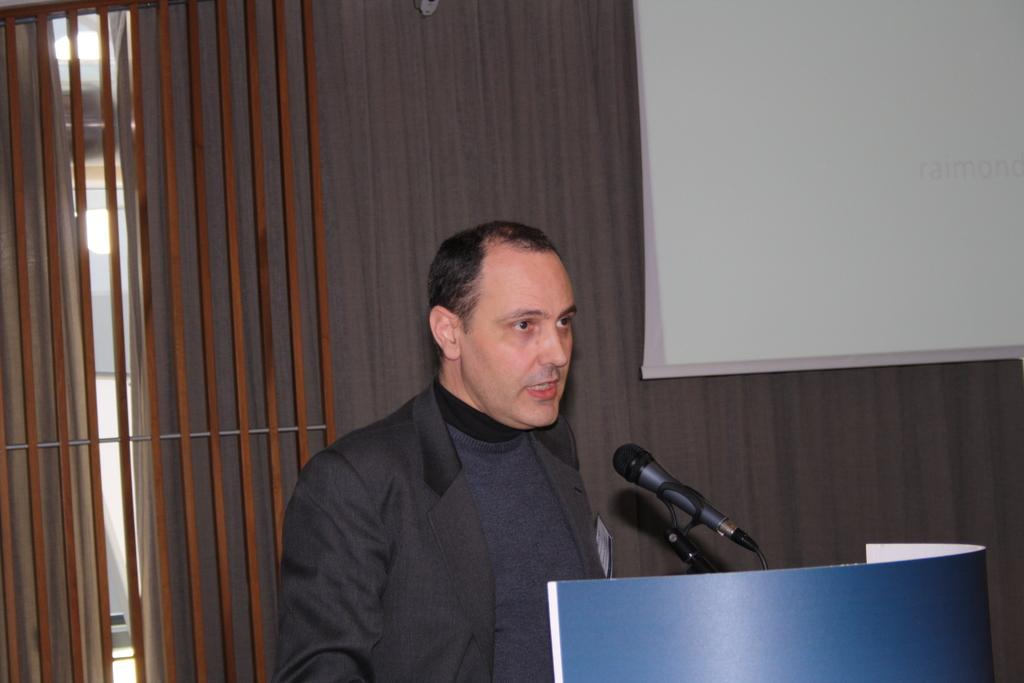What is the man in the image doing? The man is talking on a microphone. What object is present in front of the man? There is a podium in the image. What can be seen in the background behind the man? There is a curtain, lights, and a screen in the background. What type of root can be seen growing on the airplane in the image? There is no airplane or root present in the image. 